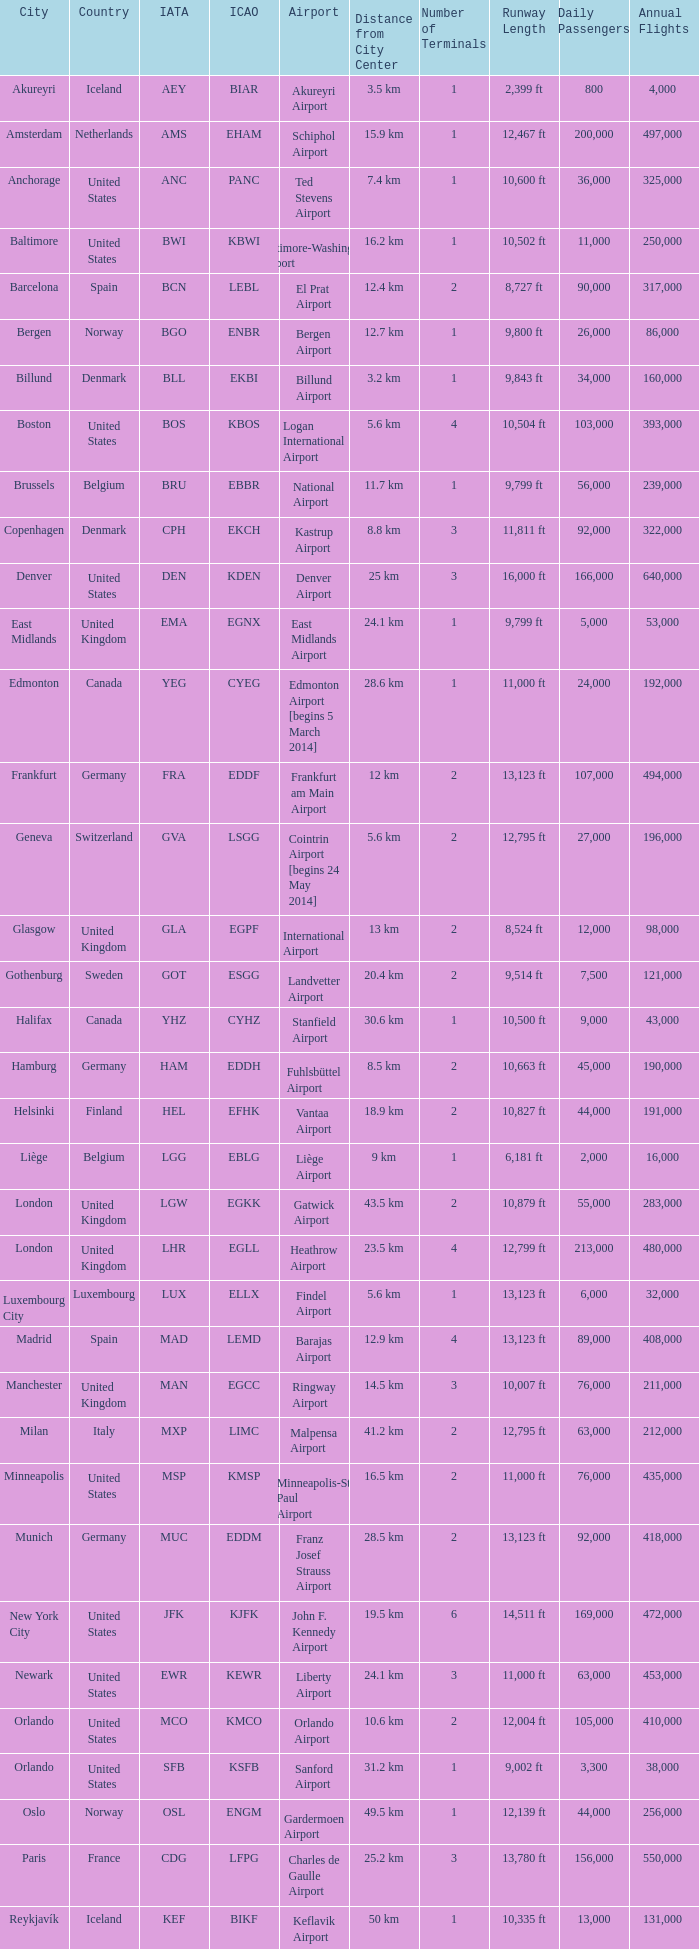What is the City with an IATA of MUC? Munich. Could you parse the entire table as a dict? {'header': ['City', 'Country', 'IATA', 'ICAO', 'Airport', 'Distance from City Center', 'Number of Terminals', 'Runway Length', 'Daily Passengers', 'Annual Flights '], 'rows': [['Akureyri', 'Iceland', 'AEY', 'BIAR', 'Akureyri Airport', '3.5 km', '1', '2,399 ft', '800', '4,000 '], ['Amsterdam', 'Netherlands', 'AMS', 'EHAM', 'Schiphol Airport', '15.9 km', '1', '12,467 ft', '200,000', '497,000 '], ['Anchorage', 'United States', 'ANC', 'PANC', 'Ted Stevens Airport', '7.4 km', '1', '10,600 ft', '36,000', '325,000 '], ['Baltimore', 'United States', 'BWI', 'KBWI', 'Baltimore-Washington Airport', '16.2 km', '1', '10,502 ft', '11,000', '250,000 '], ['Barcelona', 'Spain', 'BCN', 'LEBL', 'El Prat Airport', '12.4 km', '2', '8,727 ft', '90,000', '317,000 '], ['Bergen', 'Norway', 'BGO', 'ENBR', 'Bergen Airport', '12.7 km', '1', '9,800 ft', '26,000', '86,000 '], ['Billund', 'Denmark', 'BLL', 'EKBI', 'Billund Airport', '3.2 km', '1', '9,843 ft', '34,000', '160,000 '], ['Boston', 'United States', 'BOS', 'KBOS', 'Logan International Airport', '5.6 km', '4', '10,504 ft', '103,000', '393,000 '], ['Brussels', 'Belgium', 'BRU', 'EBBR', 'National Airport', '11.7 km', '1', '9,799 ft', '56,000', '239,000 '], ['Copenhagen', 'Denmark', 'CPH', 'EKCH', 'Kastrup Airport', '8.8 km', '3', '11,811 ft', '92,000', '322,000 '], ['Denver', 'United States', 'DEN', 'KDEN', 'Denver Airport', '25 km', '3', '16,000 ft', '166,000', '640,000 '], ['East Midlands', 'United Kingdom', 'EMA', 'EGNX', 'East Midlands Airport', '24.1 km', '1', '9,799 ft', '5,000', '53,000 '], ['Edmonton', 'Canada', 'YEG', 'CYEG', 'Edmonton Airport [begins 5 March 2014]', '28.6 km', '1', '11,000 ft', '24,000', '192,000 '], ['Frankfurt', 'Germany', 'FRA', 'EDDF', 'Frankfurt am Main Airport', '12 km', '2', '13,123 ft', '107,000', '494,000 '], ['Geneva', 'Switzerland', 'GVA', 'LSGG', 'Cointrin Airport [begins 24 May 2014]', '5.6 km', '2', '12,795 ft', '27,000', '196,000 '], ['Glasgow', 'United Kingdom', 'GLA', 'EGPF', 'International Airport', '13 km', '2', '8,524 ft', '12,000', '98,000 '], ['Gothenburg', 'Sweden', 'GOT', 'ESGG', 'Landvetter Airport', '20.4 km', '2', '9,514 ft', '7,500', '121,000 '], ['Halifax', 'Canada', 'YHZ', 'CYHZ', 'Stanfield Airport', '30.6 km', '1', '10,500 ft', '9,000', '43,000 '], ['Hamburg', 'Germany', 'HAM', 'EDDH', 'Fuhlsbüttel Airport', '8.5 km', '2', '10,663 ft', '45,000', '190,000 '], ['Helsinki', 'Finland', 'HEL', 'EFHK', 'Vantaa Airport', '18.9 km', '2', '10,827 ft', '44,000', '191,000 '], ['Liège', 'Belgium', 'LGG', 'EBLG', 'Liège Airport', '9 km', '1', '6,181 ft', '2,000', '16,000 '], ['London', 'United Kingdom', 'LGW', 'EGKK', 'Gatwick Airport', '43.5 km', '2', '10,879 ft', '55,000', '283,000 '], ['London', 'United Kingdom', 'LHR', 'EGLL', 'Heathrow Airport', '23.5 km', '4', '12,799 ft', '213,000', '480,000 '], ['Luxembourg City', 'Luxembourg', 'LUX', 'ELLX', 'Findel Airport', '5.6 km', '1', '13,123 ft', '6,000', '32,000 '], ['Madrid', 'Spain', 'MAD', 'LEMD', 'Barajas Airport', '12.9 km', '4', '13,123 ft', '89,000', '408,000 '], ['Manchester', 'United Kingdom', 'MAN', 'EGCC', 'Ringway Airport', '14.5 km', '3', '10,007 ft', '76,000', '211,000 '], ['Milan', 'Italy', 'MXP', 'LIMC', 'Malpensa Airport', '41.2 km', '2', '12,795 ft', '63,000', '212,000 '], ['Minneapolis', 'United States', 'MSP', 'KMSP', 'Minneapolis-St Paul Airport', '16.5 km', '2', '11,000 ft', '76,000', '435,000 '], ['Munich', 'Germany', 'MUC', 'EDDM', 'Franz Josef Strauss Airport', '28.5 km', '2', '13,123 ft', '92,000', '418,000 '], ['New York City', 'United States', 'JFK', 'KJFK', 'John F. Kennedy Airport', '19.5 km', '6', '14,511 ft', '169,000', '472,000 '], ['Newark', 'United States', 'EWR', 'KEWR', 'Liberty Airport', '24.1 km', '3', '11,000 ft', '63,000', '453,000 '], ['Orlando', 'United States', 'MCO', 'KMCO', 'Orlando Airport', '10.6 km', '2', '12,004 ft', '105,000', '410,000 '], ['Orlando', 'United States', 'SFB', 'KSFB', 'Sanford Airport', '31.2 km', '1', '9,002 ft', '3,300', '38,000 '], ['Oslo', 'Norway', 'OSL', 'ENGM', 'Gardermoen Airport', '49.5 km', '1', '12,139 ft', '44,000', '256,000 '], ['Paris', 'France', 'CDG', 'LFPG', 'Charles de Gaulle Airport', '25.2 km', '3', '13,780 ft', '156,000', '550,000 '], ['Reykjavík', 'Iceland', 'KEF', 'BIKF', 'Keflavik Airport', '50 km', '1', '10,335 ft', '13,000', '131,000 '], ['Saint Petersburg', 'Russia', 'LED', 'ULLI', 'Pulkovo Airport', '17 km', '2', '11,483 ft', '19,000', '115,000 '], ['San Francisco', 'United States', 'SFO', 'KSFO', 'San Francisco Airport', '21.7 km', '4', '10,602 ft', '59,000', '380,000 '], ['Seattle', 'United States', 'SEA', 'KSEA', 'Seattle–Tacoma Airport', '22.5 km', '1', '11,901 ft', '50,000', '416,000 '], ['Stavanger', 'Norway', 'SVG', 'ENZV', 'Sola Airport', '11.9 km', '1', '9,022 ft', '5,000', '66,000 '], ['Stockholm', 'Sweden', 'ARN', 'ESSA', 'Arlanda Airport', '37.5 km', '4', '10,102 ft', '74,000', '276,000 '], ['Toronto', 'Canada', 'YYZ', 'CYYZ', 'Pearson Airport', '22.6 km', '2', '11,120 ft', '110,000', '491,000 '], ['Trondheim', 'Norway', 'TRD', 'ENVA', 'Trondheim Airport', '32.4 km', '1', '9,022 ft', '8,000', '92,000 '], ['Vancouver', 'Canada', 'YVR', 'CYVR', 'Vancouver Airport [begins 13 May 2014]', '11.5 km', '3', '10,500 ft', '55,000', '333,000 '], ['Washington, D.C.', 'United States', 'IAD', 'KIAD', 'Dulles Airport', '42.2 km', '1', '11,500 ft', '29,000', '200,000 '], ['Zurich', 'Switzerland', 'ZRH', 'LSZH', 'Kloten Airport', '10.6 km', '3', '12,139 ft', '68,000', '305,000']]} 